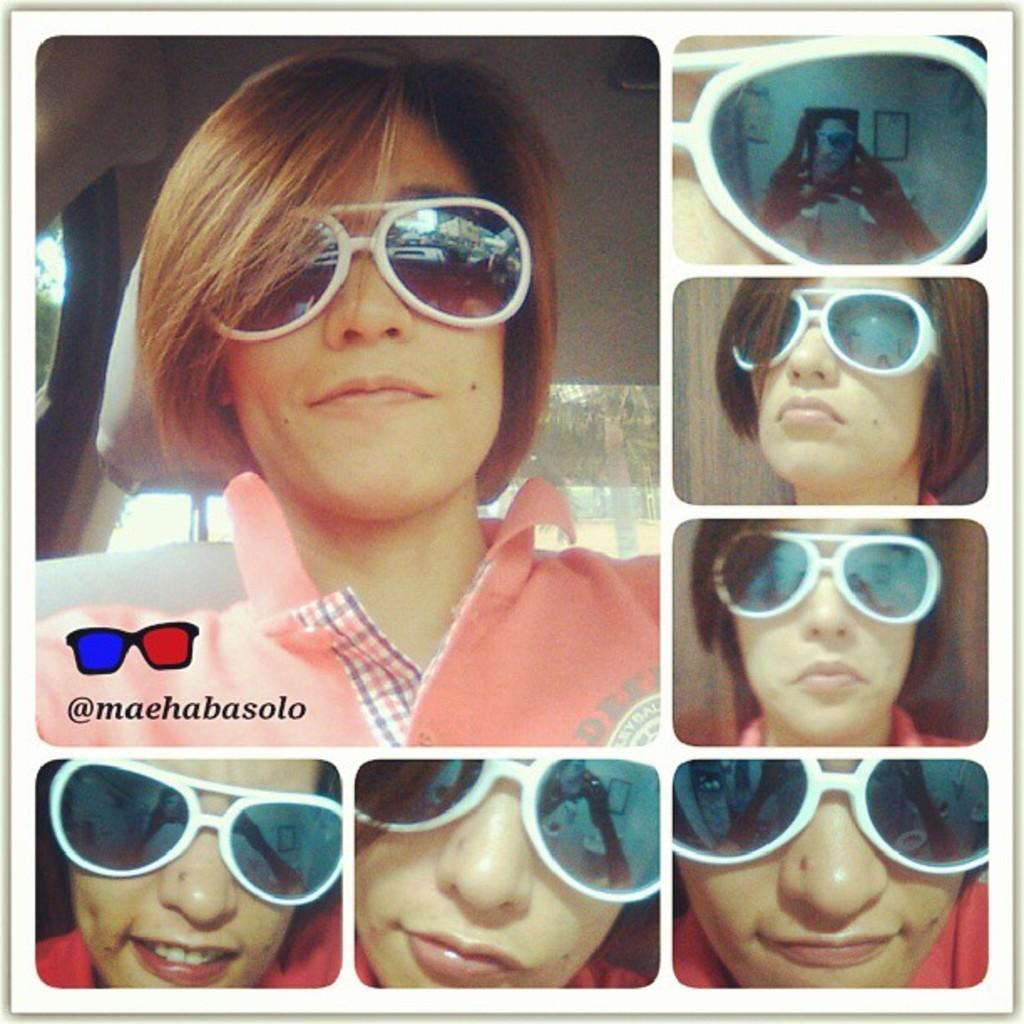In one or two sentences, can you explain what this image depicts? This is a collage image. In each image we can see see the same person face and goggles but different expressions. On the right at the top corner we can see the reflection of a person holding a mobile in the hands on the googles. 